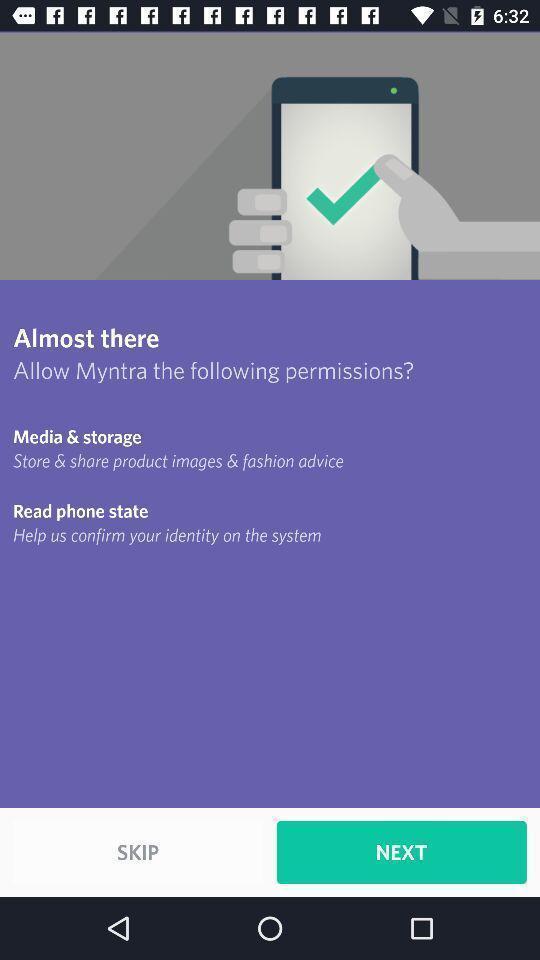Describe the content in this image. Screen shows next to an app. 